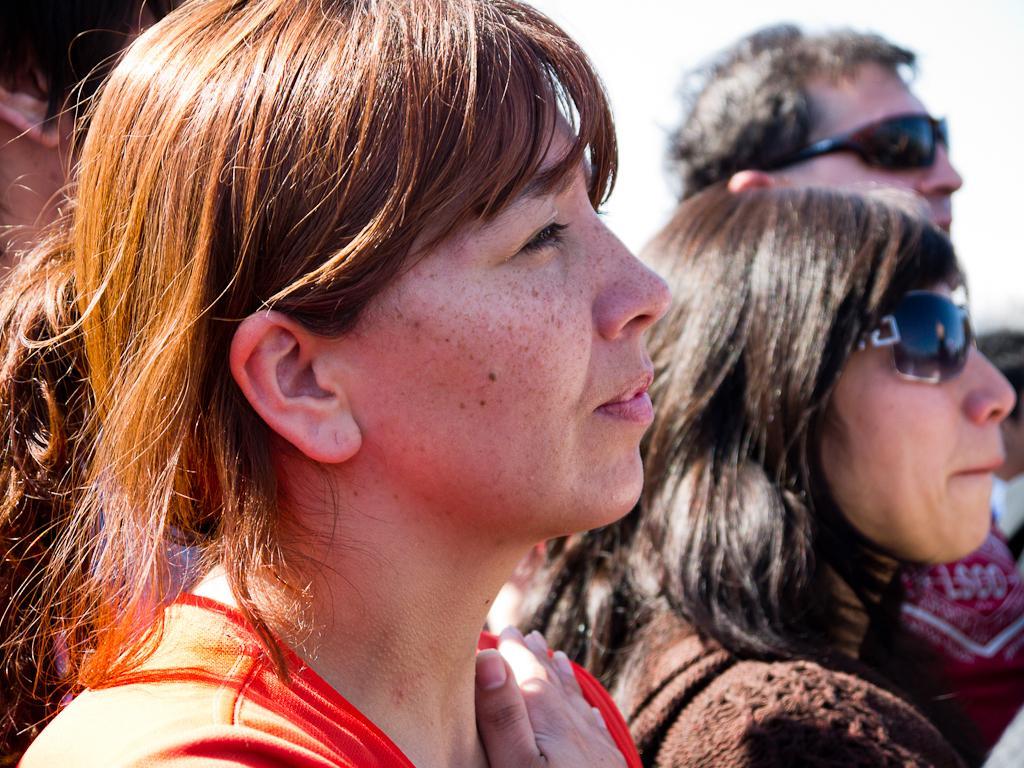Please provide a concise description of this image. In this image there are persons. 